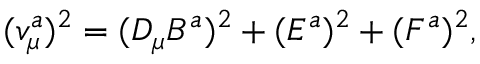<formula> <loc_0><loc_0><loc_500><loc_500>( v _ { \mu } ^ { a } ) ^ { 2 } = ( D _ { \mu } B ^ { a } ) ^ { 2 } + ( E ^ { a } ) ^ { 2 } + ( F ^ { a } ) ^ { 2 } ,</formula> 